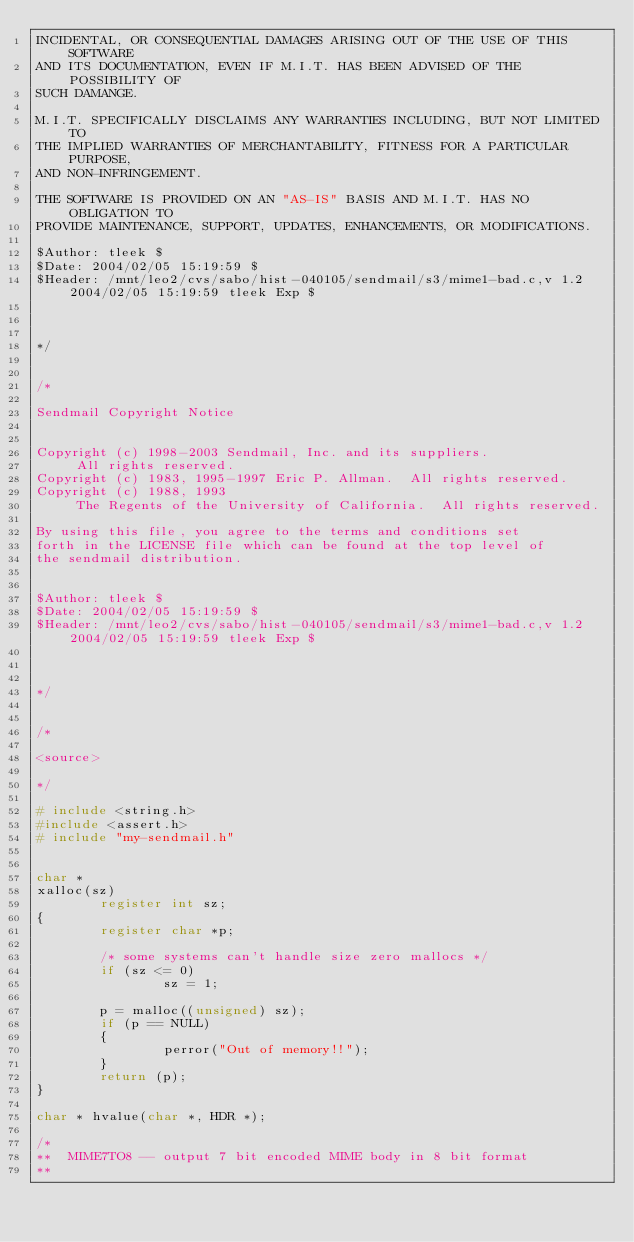Convert code to text. <code><loc_0><loc_0><loc_500><loc_500><_C_>INCIDENTAL, OR CONSEQUENTIAL DAMAGES ARISING OUT OF THE USE OF THIS SOFTWARE 
AND ITS DOCUMENTATION, EVEN IF M.I.T. HAS BEEN ADVISED OF THE POSSIBILITY OF 
SUCH DAMANGE.

M.I.T. SPECIFICALLY DISCLAIMS ANY WARRANTIES INCLUDING, BUT NOT LIMITED TO 
THE IMPLIED WARRANTIES OF MERCHANTABILITY, FITNESS FOR A PARTICULAR PURPOSE, 
AND NON-INFRINGEMENT.

THE SOFTWARE IS PROVIDED ON AN "AS-IS" BASIS AND M.I.T. HAS NO OBLIGATION TO 
PROVIDE MAINTENANCE, SUPPORT, UPDATES, ENHANCEMENTS, OR MODIFICATIONS.

$Author: tleek $
$Date: 2004/02/05 15:19:59 $
$Header: /mnt/leo2/cvs/sabo/hist-040105/sendmail/s3/mime1-bad.c,v 1.2 2004/02/05 15:19:59 tleek Exp $



*/


/*

Sendmail Copyright Notice


Copyright (c) 1998-2003 Sendmail, Inc. and its suppliers.
     All rights reserved.
Copyright (c) 1983, 1995-1997 Eric P. Allman.  All rights reserved.
Copyright (c) 1988, 1993
     The Regents of the University of California.  All rights reserved.

By using this file, you agree to the terms and conditions set
forth in the LICENSE file which can be found at the top level of
the sendmail distribution.


$Author: tleek $
$Date: 2004/02/05 15:19:59 $
$Header: /mnt/leo2/cvs/sabo/hist-040105/sendmail/s3/mime1-bad.c,v 1.2 2004/02/05 15:19:59 tleek Exp $



*/


/*

<source>

*/

# include <string.h>
#include <assert.h>
# include "my-sendmail.h"


char *
xalloc(sz)
        register int sz;
{
        register char *p;
 
        /* some systems can't handle size zero mallocs */
        if (sz <= 0)
                sz = 1;
 
        p = malloc((unsigned) sz);
        if (p == NULL)
        {
                perror("Out of memory!!");
        }
        return (p);
}

char * hvalue(char *, HDR *);

/*
**  MIME7TO8 -- output 7 bit encoded MIME body in 8 bit format
**</code> 